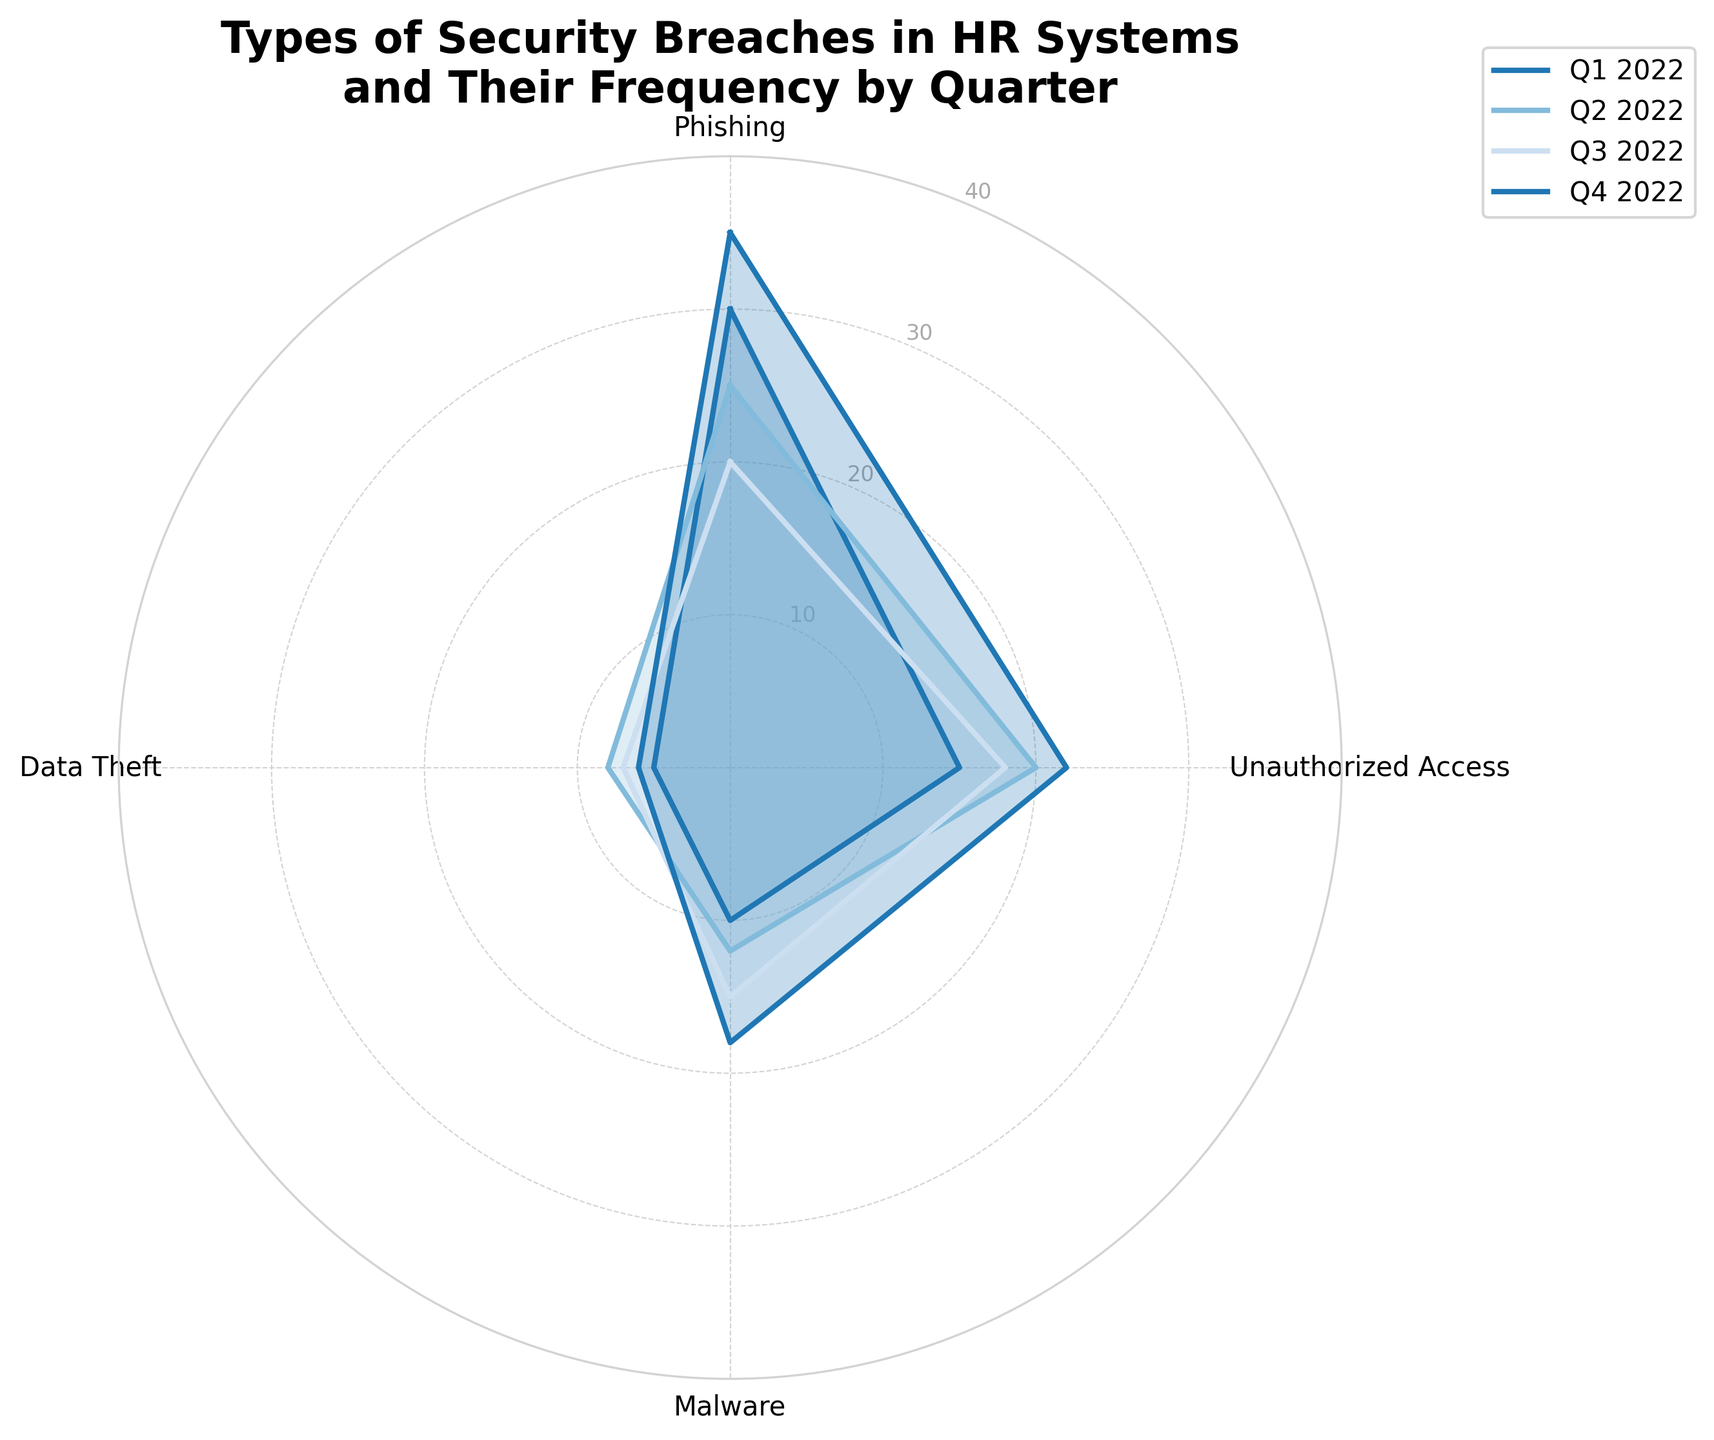What's the title of the radar chart? The title of the radar chart is displayed at the top and summarizes the content of the chart.
Answer: Types of Security Breaches in HR Systems and Their Frequency by Quarter What does the radar chart represent? The radar chart represents the frequency of different types of security breaches in HR systems over four quarters (Q1 2022 to Q4 2022).
Answer: Frequency of different types of security breaches in HR systems over time How many categories of security breaches are displayed? By counting the labels around the radar chart, you can see that there are four categories of security breaches.
Answer: Four In which quarter was the highest number of phishing incidents recorded? The data points on the radar chart show the frequency of phishing incidents for each quarter. The highest value can be identified as the one furthest from the center along the "Phishing" axis, which is Q4 2022 with a value of 35.
Answer: Q4 2022 Which type of security breach had the smallest number reported in Q3 2022? By examining the values for Q3 2022 on the radar chart for each type of security breach, you can identify the smallest number, which corresponds to "Data Theft" with a value of 7.
Answer: Data Theft What is the average number of unauthorized access incidents per quarter? Sum the values of unauthorized access incidents across all quarters (15+20+18+22 = 75) and then divide by the number of quarters (75/4).
Answer: 18.75 Which quarter had the least number of malware incidents, and what was that number? By comparing the values for malware incidents across all quarters, the lowest can be seen in Q1 2022, which is 10.
Answer: Q1 2022, 10 Which type of security breach showed a general increasing trend over the quarters? By observing the plotted lines for each type of security breach, "Malware" shows a general increasing trend from 10 in Q1 to 18 in Q4.
Answer: Malware How do the number of incidents in Q2 2022 for phishing and data theft compare? The radar chart shows the values for Q2 2022 for phishing (25) and data theft (8). Comparing these, phishing incidents are greater than data theft incidents.
Answer: Phishing incidents are greater than data theft incidents Between Q3 2022 and Q4 2022, which category saw the largest increase in the number of incidents? By comparing the data between Q3 and Q4 2022 for all categories, "Phishing" saw the largest increase from 20 to 35, an increase of 15.
Answer: Phishing 